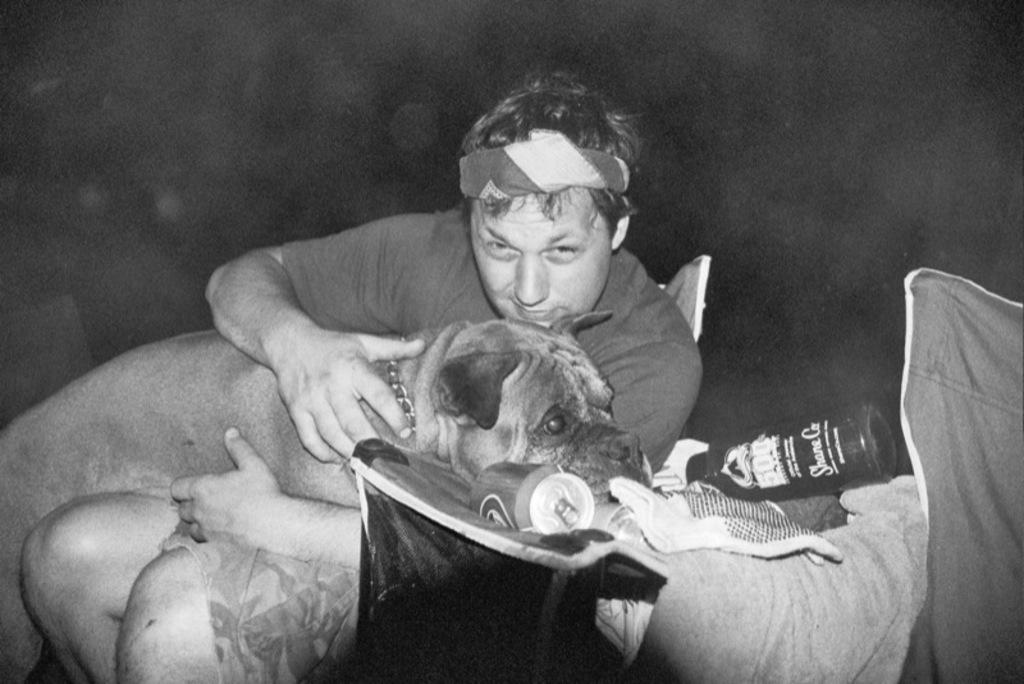Who or what is present in the image? There is a person and a dog in the image. What objects can be seen in the image? There is a can and a bottle in the image. What type of pollution is visible in the image? There is no visible pollution in the image. Is there a notebook present in the image? There is no notebook present in the image. 